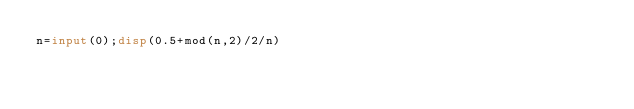Convert code to text. <code><loc_0><loc_0><loc_500><loc_500><_Octave_>n=input(0);disp(0.5+mod(n,2)/2/n)</code> 